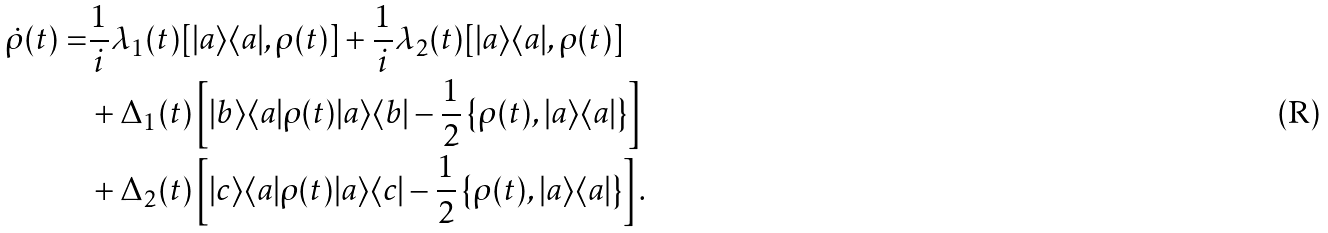<formula> <loc_0><loc_0><loc_500><loc_500>\dot { \rho } ( t ) = & \frac { 1 } { i } \lambda _ { 1 } ( t ) [ | a \rangle \langle a | , \rho ( t ) ] + \frac { 1 } { i } \lambda _ { 2 } ( t ) [ | a \rangle \langle a | , \rho ( t ) ] \\ & + \Delta _ { 1 } ( t ) \left [ | b \rangle \langle a | \rho ( t ) | a \rangle \langle b | - \frac { 1 } { 2 } \left \{ \rho ( t ) , | a \rangle \langle a | \right \} \right ] \\ & + \Delta _ { 2 } ( t ) \left [ | c \rangle \langle a | \rho ( t ) | a \rangle \langle c | - \frac { 1 } { 2 } \left \{ \rho ( t ) , | a \rangle \langle a | \right \} \right ] .</formula> 